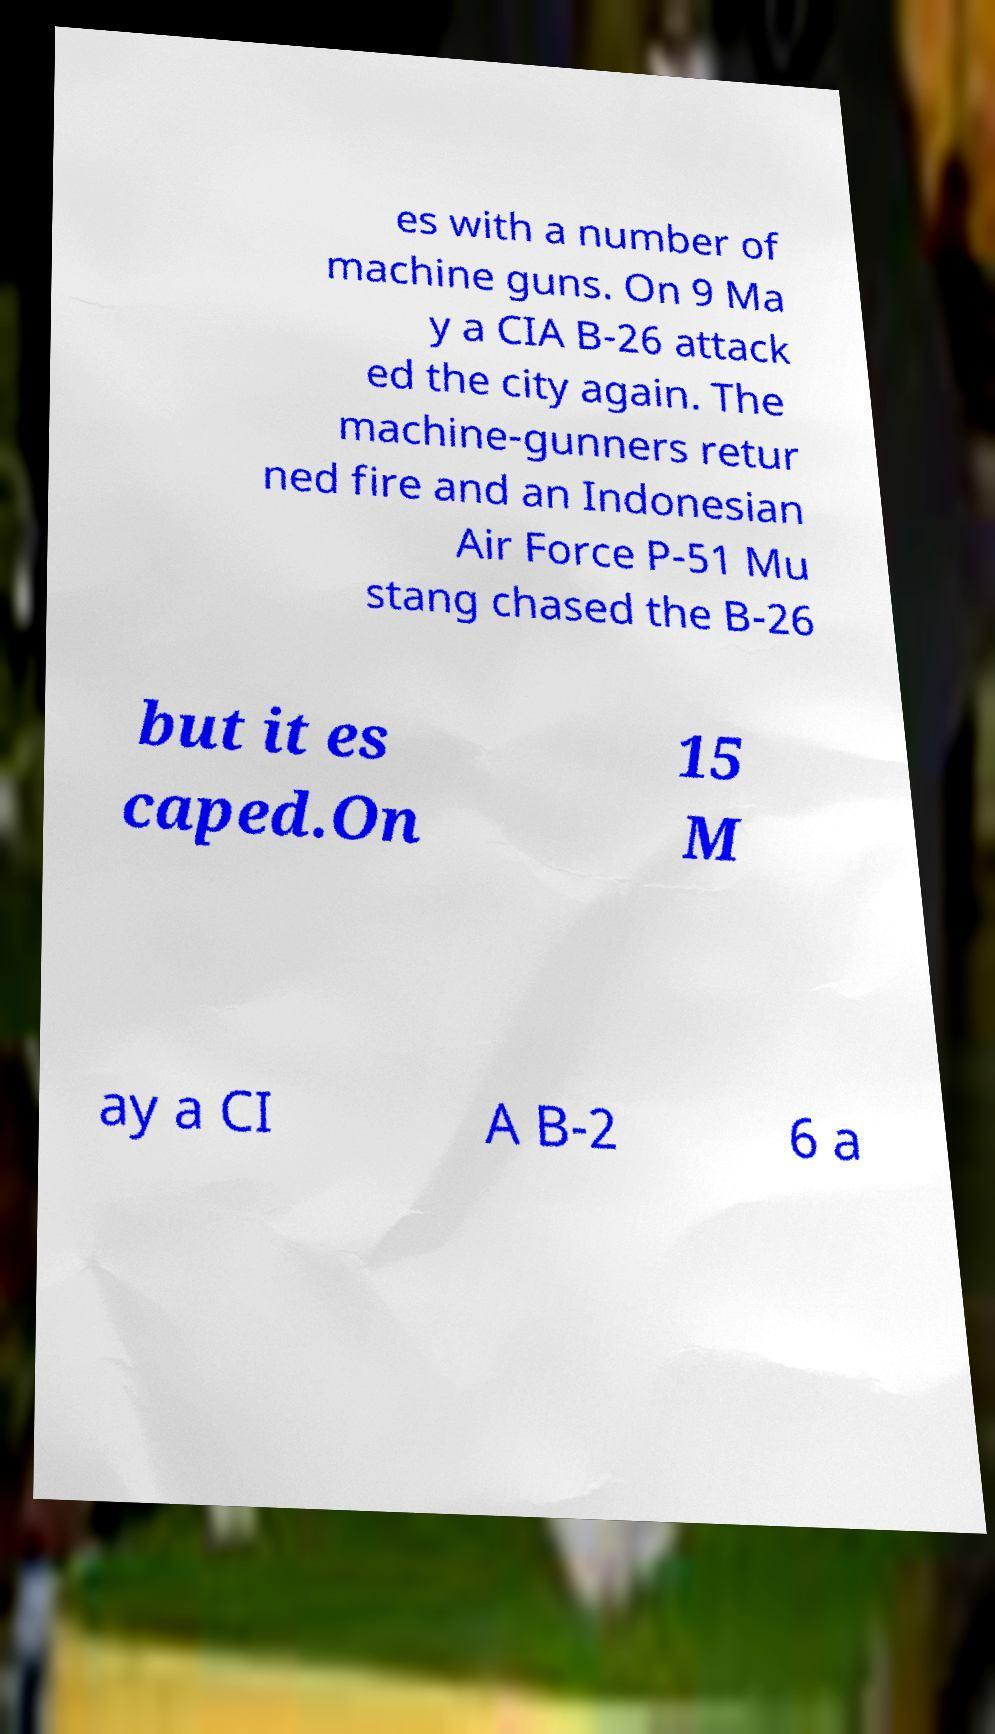I need the written content from this picture converted into text. Can you do that? es with a number of machine guns. On 9 Ma y a CIA B-26 attack ed the city again. The machine-gunners retur ned fire and an Indonesian Air Force P-51 Mu stang chased the B-26 but it es caped.On 15 M ay a CI A B-2 6 a 